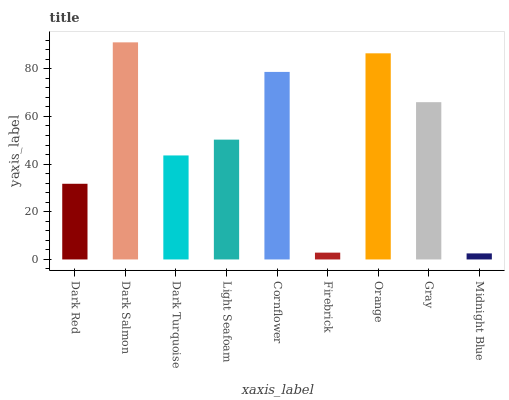Is Midnight Blue the minimum?
Answer yes or no. Yes. Is Dark Salmon the maximum?
Answer yes or no. Yes. Is Dark Turquoise the minimum?
Answer yes or no. No. Is Dark Turquoise the maximum?
Answer yes or no. No. Is Dark Salmon greater than Dark Turquoise?
Answer yes or no. Yes. Is Dark Turquoise less than Dark Salmon?
Answer yes or no. Yes. Is Dark Turquoise greater than Dark Salmon?
Answer yes or no. No. Is Dark Salmon less than Dark Turquoise?
Answer yes or no. No. Is Light Seafoam the high median?
Answer yes or no. Yes. Is Light Seafoam the low median?
Answer yes or no. Yes. Is Midnight Blue the high median?
Answer yes or no. No. Is Dark Red the low median?
Answer yes or no. No. 